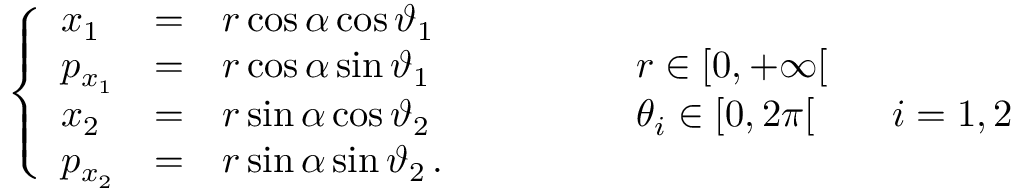<formula> <loc_0><loc_0><loc_500><loc_500>\left \{ \begin{array} { l c l l } { x _ { 1 } } & { = } & { r \cos \alpha \cos \vartheta _ { 1 } } \\ { p _ { x _ { 1 } } } & { = } & { r \cos \alpha \sin \vartheta _ { 1 } } & { \quad r \in [ 0 , + \infty [ } \\ { x _ { 2 } } & { = } & { r \sin \alpha \cos \vartheta _ { 2 } } & { \quad \theta _ { i } \in [ 0 , 2 \pi [ \quad i = 1 , 2 } \\ { p _ { x _ { 2 } } } & { = } & { r \sin \alpha \sin \vartheta _ { 2 } \, . } \end{array}</formula> 